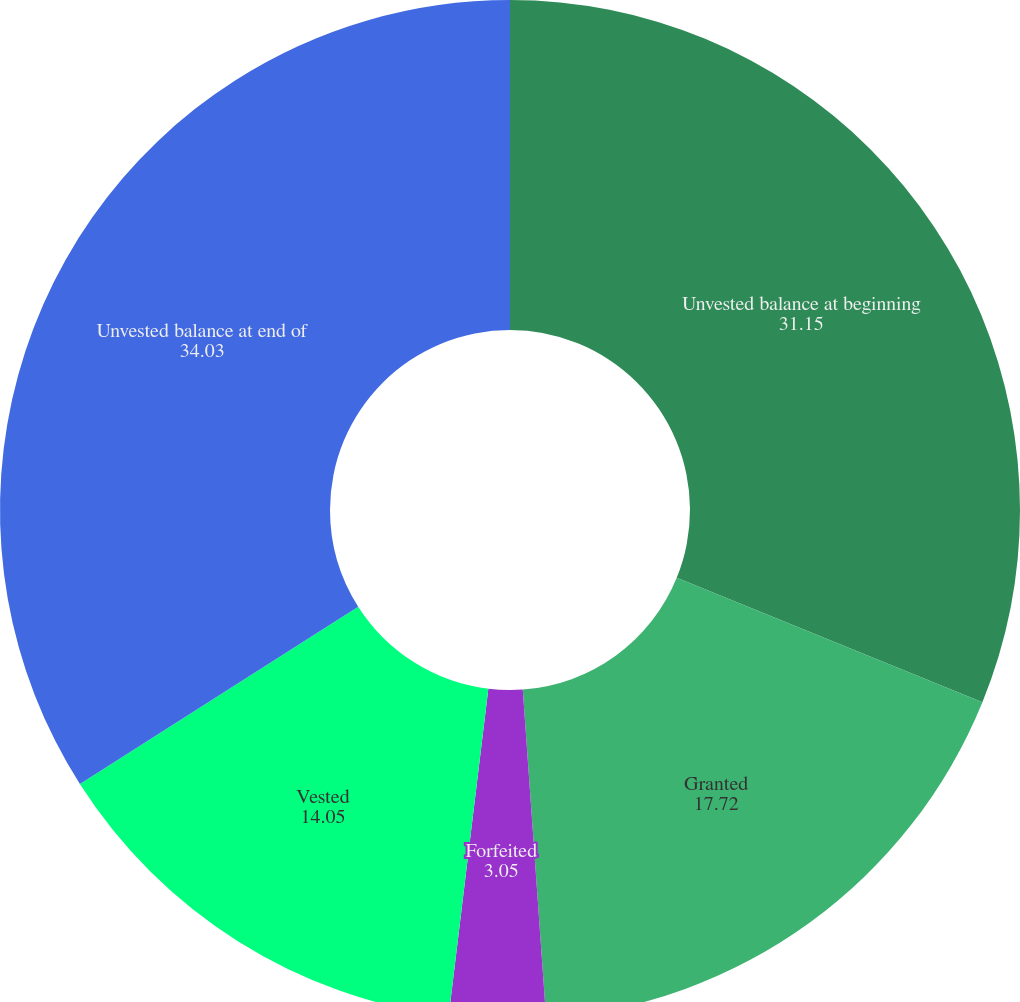Convert chart to OTSL. <chart><loc_0><loc_0><loc_500><loc_500><pie_chart><fcel>Unvested balance at beginning<fcel>Granted<fcel>Forfeited<fcel>Vested<fcel>Unvested balance at end of<nl><fcel>31.15%<fcel>17.72%<fcel>3.05%<fcel>14.05%<fcel>34.03%<nl></chart> 